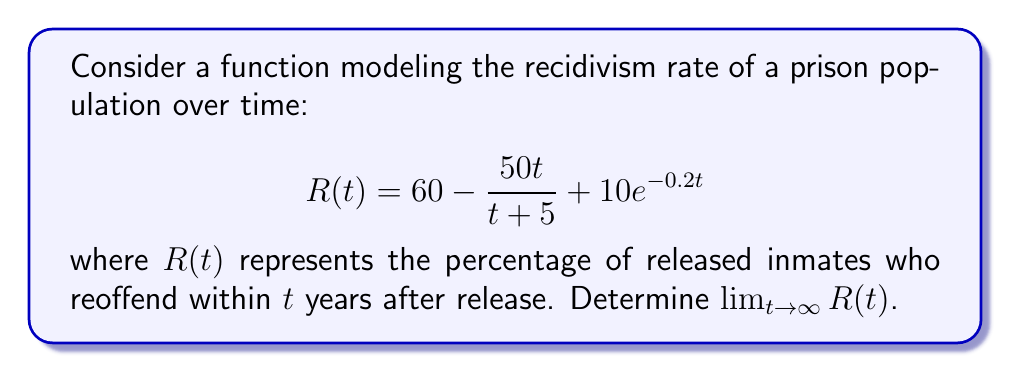Help me with this question. To find the limit of $R(t)$ as $t$ approaches infinity, we need to evaluate each term of the function separately:

1) The constant term: $60$
   This term remains unchanged as $t$ approaches infinity.

2) The rational term: $-\frac{50t}{t+5}$
   As $t$ approaches infinity, both numerator and denominator grow, but at the same rate. We can evaluate this limit:
   
   $$\lim_{t \to \infty} -\frac{50t}{t+5} = -\lim_{t \to \infty} \frac{50}{1 + \frac{5}{t}} = -50$$

3) The exponential term: $10e^{-0.2t}$
   As $t$ approaches infinity, the exponent becomes increasingly negative, causing this term to approach zero:
   
   $$\lim_{t \to \infty} 10e^{-0.2t} = 0$$

Now, we can combine these results:

$$\lim_{t \to \infty} R(t) = \lim_{t \to \infty} (60 - \frac{50t}{t+5} + 10e^{-0.2t})$$
$$= 60 + (-50) + 0 = 10$$

This result suggests that in the long term, the recidivism rate approaches 10%, indicating that rehabilitation efforts and time since release have a significant impact on reducing repeat offenses.
Answer: $\lim_{t \to \infty} R(t) = 10$ 